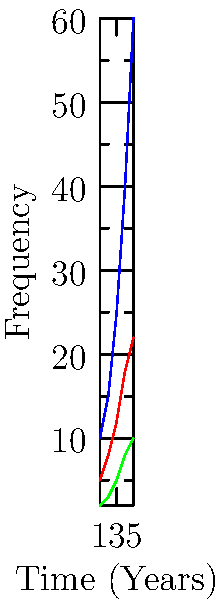Based on the graph showing different types of police-community interactions over time, which interaction type shows the steepest increase and might be the most promising area for building trust between police and the community? To determine which interaction type shows the steepest increase and might be most promising for building trust, we need to analyze the slopes of each line:

1. Community Outreach (blue line):
   - Starts at 10 and ends at 60
   - Slope = (60 - 10) / (5 - 1) = 50 / 4 = 12.5

2. Traffic Stops (red line):
   - Starts at 5 and ends at 22
   - Slope = (22 - 5) / (5 - 1) = 17 / 4 = 4.25

3. Emergency Response (green line):
   - Starts at 2 and ends at 10
   - Slope = (10 - 2) / (5 - 1) = 8 / 4 = 2

The Community Outreach line has the steepest slope at 12.5, indicating the fastest growth over time.

For building trust:
1. Community Outreach involves direct, positive interactions with the public.
2. Its rapid increase suggests a growing emphasis on this approach.
3. More frequent positive interactions can lead to improved relationships and trust.

Therefore, Community Outreach shows the steepest increase and is likely the most promising area for building trust between police and the community.
Answer: Community Outreach 